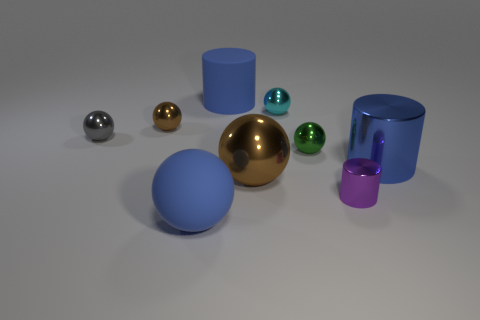What is the material of the big blue ball that is in front of the blue cylinder behind the small gray sphere that is on the left side of the blue ball?
Provide a short and direct response. Rubber. The blue cylinder that is to the right of the green object behind the large blue metallic cylinder is made of what material?
Keep it short and to the point. Metal. Is the number of small cyan objects that are behind the large matte cylinder less than the number of big rubber balls?
Ensure brevity in your answer.  Yes. There is a large blue thing that is behind the gray shiny object; what shape is it?
Provide a succinct answer. Cylinder. Is the size of the green metal ball the same as the blue rubber thing that is behind the gray ball?
Your answer should be compact. No. Are there any other small purple cylinders made of the same material as the small purple cylinder?
Keep it short and to the point. No. What number of balls are either tiny brown metallic things or large rubber things?
Your response must be concise. 2. Is there a big blue metallic thing right of the blue thing that is on the right side of the tiny green metal sphere?
Offer a terse response. No. Are there fewer tiny objects than purple objects?
Offer a terse response. No. How many small brown shiny things have the same shape as the purple shiny thing?
Offer a very short reply. 0. 